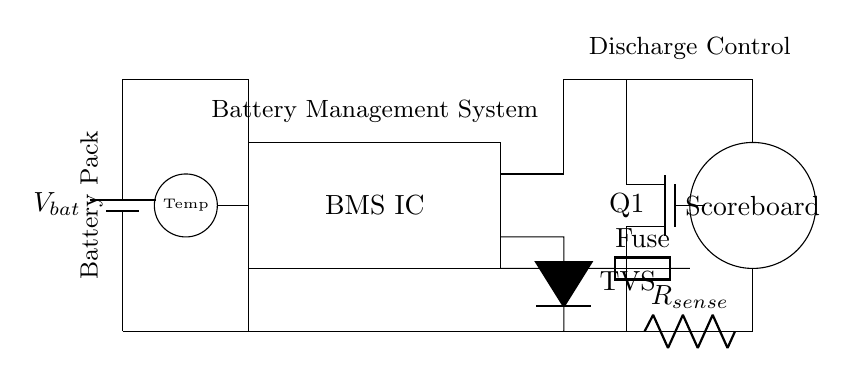What type of battery is used in this circuit? The circuit shows a battery symbol labeled with V bat, indicating it is a voltage source. The specific type of battery is not detailed, but it is typically a rechargeable type in battery management systems.
Answer: Voltage source What is the primary function of the BMS IC? The BMS IC (Battery Management System Integrated Circuit) is responsible for managing the battery's performance, ensuring safe charging and discharging, and monitoring battery health and temperature. Its placement indicates it is central to system control.
Answer: Battery management What component senses current in this circuit? The component labeled R sense is clearly identified in the diagram and is dedicated to measuring the current flowing through the circuit. Its position indicates it is effectively placed in series with the load.
Answer: Current sense resistor Where is the temperature sensor located? The temperature sensor is represented by a small circle labeled "Temp" at the position (1, 2) in the circuit diagram, which is close to the BMS IC, indicating it monitors the battery's temperature for safety.
Answer: Close to BMS IC How does the circuit prevent overcurrent? The fuse is specifically placed in series with the main current flow path to the scoreboard and operates by breaking the circuit if current exceeds a safe limit, thereby protecting the circuit from damage due to overcurrent.
Answer: Fuse What is the purpose of the TVS diode in this circuit? The TVS (Transient Voltage Suppressor) diode is used to protect sensitive components from voltage spikes or transients by clamping the voltage to a safe level, thus preventing potential damage to the BMS IC and connected components.
Answer: Voltage spike protection What controls the discharge of the battery? The MOSFET labeled Q1 is controlling the discharge in the circuit, as indicated by the connections suggesting it can switch the current on or off based on the BMS commands, regulating the power delivered to the scoreboard.
Answer: MOSFET 